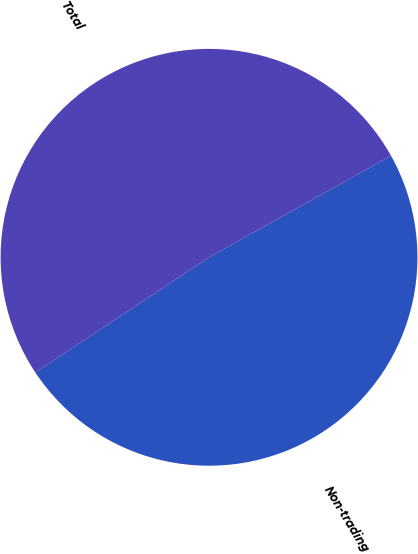Convert chart to OTSL. <chart><loc_0><loc_0><loc_500><loc_500><pie_chart><fcel>Non-trading<fcel>Total<nl><fcel>48.78%<fcel>51.22%<nl></chart> 